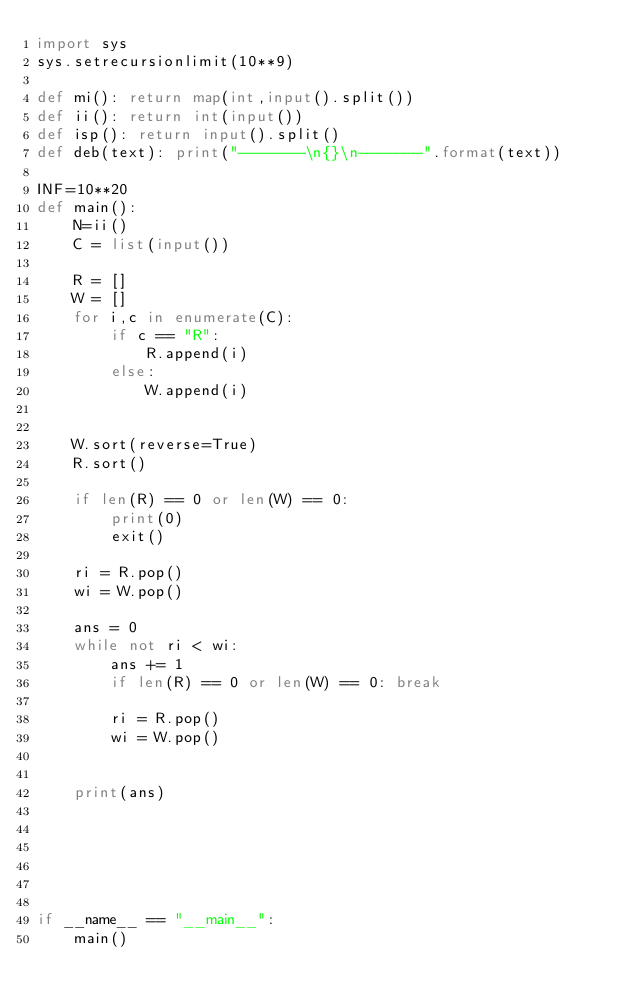Convert code to text. <code><loc_0><loc_0><loc_500><loc_500><_Python_>import sys
sys.setrecursionlimit(10**9)

def mi(): return map(int,input().split())
def ii(): return int(input())
def isp(): return input().split()
def deb(text): print("-------\n{}\n-------".format(text))

INF=10**20
def main():
    N=ii()
    C = list(input())

    R = []
    W = []
    for i,c in enumerate(C):
        if c == "R":
            R.append(i)
        else:
            W.append(i)
    

    W.sort(reverse=True)
    R.sort()

    if len(R) == 0 or len(W) == 0:
        print(0)
        exit()

    ri = R.pop()
    wi = W.pop()

    ans = 0
    while not ri < wi:
        ans += 1
        if len(R) == 0 or len(W) == 0: break

        ri = R.pop()
        wi = W.pop()    


    print(ans)






if __name__ == "__main__":
    main()</code> 